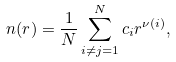Convert formula to latex. <formula><loc_0><loc_0><loc_500><loc_500>n ( r ) = \frac { 1 } { N } \sum _ { i \ne j = 1 } ^ { N } c _ { i } r ^ { \nu ( i ) } ,</formula> 